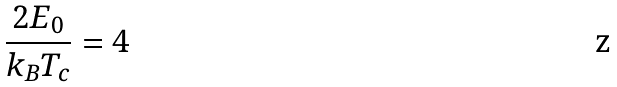Convert formula to latex. <formula><loc_0><loc_0><loc_500><loc_500>\frac { 2 E _ { 0 } } { k _ { B } T _ { c } } = 4</formula> 